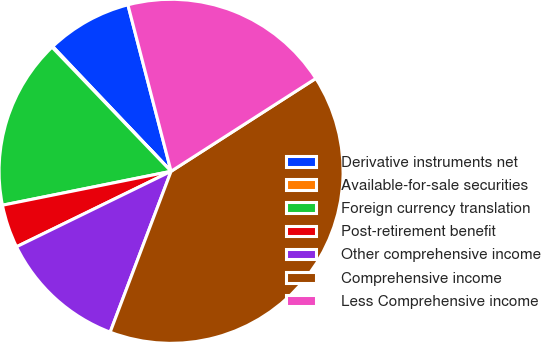Convert chart. <chart><loc_0><loc_0><loc_500><loc_500><pie_chart><fcel>Derivative instruments net<fcel>Available-for-sale securities<fcel>Foreign currency translation<fcel>Post-retirement benefit<fcel>Other comprehensive income<fcel>Comprehensive income<fcel>Less Comprehensive income<nl><fcel>8.04%<fcel>0.09%<fcel>15.99%<fcel>4.07%<fcel>12.01%<fcel>39.84%<fcel>19.96%<nl></chart> 